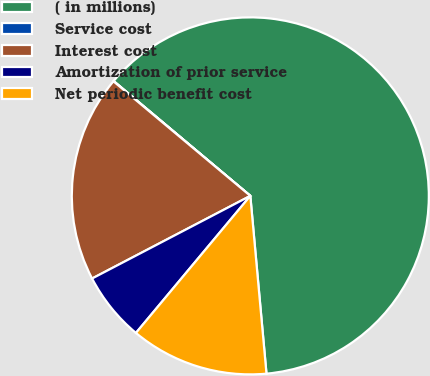Convert chart. <chart><loc_0><loc_0><loc_500><loc_500><pie_chart><fcel>( in millions)<fcel>Service cost<fcel>Interest cost<fcel>Amortization of prior service<fcel>Net periodic benefit cost<nl><fcel>62.43%<fcel>0.03%<fcel>18.75%<fcel>6.27%<fcel>12.51%<nl></chart> 